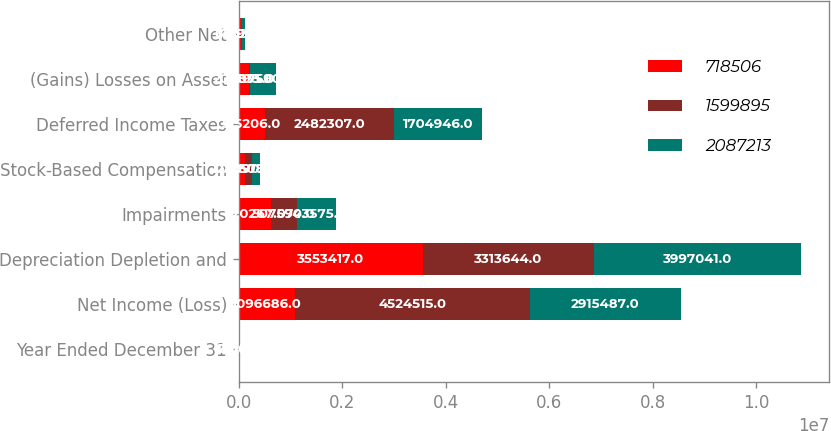Convert chart to OTSL. <chart><loc_0><loc_0><loc_500><loc_500><stacked_bar_chart><ecel><fcel>Year Ended December 31<fcel>Net Income (Loss)<fcel>Depreciation Depletion and<fcel>Impairments<fcel>Stock-Based Compensation<fcel>Deferred Income Taxes<fcel>(Gains) Losses on Asset<fcel>Other Net<nl><fcel>718506<fcel>2016<fcel>1.09669e+06<fcel>3.55342e+06<fcel>620267<fcel>128090<fcel>515206<fcel>205835<fcel>61690<nl><fcel>1.5999e+06<fcel>2015<fcel>4.52452e+06<fcel>3.31364e+06<fcel>507590<fcel>130577<fcel>2.48231e+06<fcel>8798<fcel>11896<nl><fcel>2.08721e+06<fcel>2014<fcel>2.91549e+06<fcel>3.99704e+06<fcel>743575<fcel>145086<fcel>1.70495e+06<fcel>507590<fcel>48138<nl></chart> 